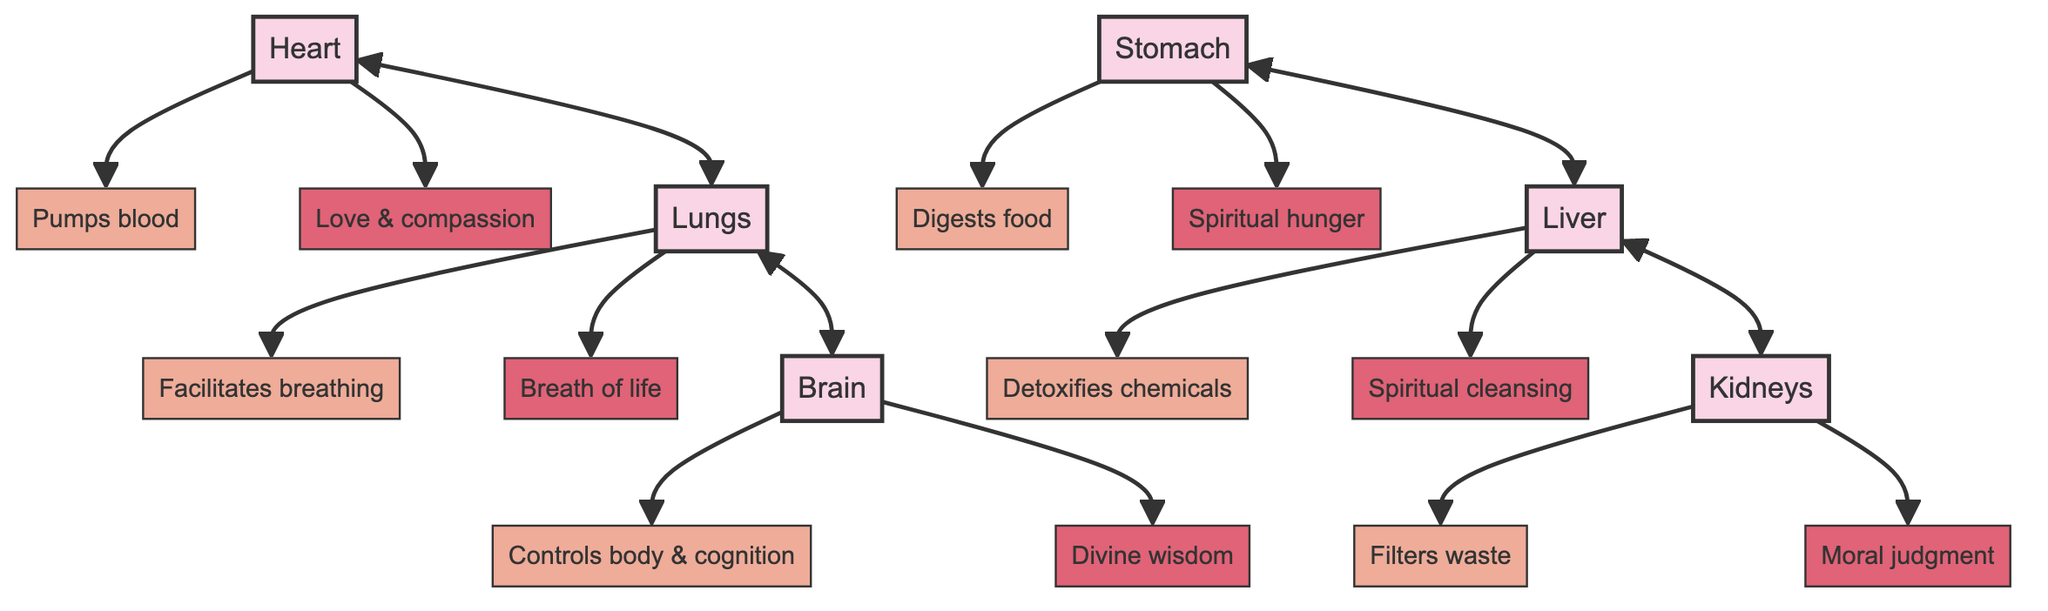What is the function of the heart? The heart is connected to the node labeled "Pumps blood," which directly indicates its primary function in the diagram.
Answer: Pumps blood What spiritual symbolism is associated with the brain? The brain is linked to "Divine wisdom," which is shown next to the brain in the diagram, representing its spiritual interpretation.
Answer: Divine wisdom Which organ is connected to both the liver and kidneys? The diagram shows a direct connection between the liver and kidneys, indicating that the liver is associated with the kidneys in their relationships.
Answer: Liver How many organs are represented in the diagram? By counting the distinct organ nodes labeled in the diagram, there are a total of six organs: heart, lungs, brain, liver, kidneys, and stomach.
Answer: 6 What is the symbolism associated with the lungs? The lungs are associated with "Breath of life," as specified next to the lungs in the diagram, which embodies its spiritual interpretation.
Answer: Breath of life What is the relationship between the stomach and liver? The diagram indicates a connection between the stomach and the liver, suggesting an interaction or influence between these two organs.
Answer: Connected Which organ is responsible for detoxification? The function node connected to the liver states "Detoxifies chemicals," which directly addresses the organ responsible for detoxification in the body.
Answer: Liver Which organ’s function involves waste filtering? The kidneys' function node is labeled "Filters waste," clearly indicating that this organ is responsible for filtering waste products from the body.
Answer: Kidneys How does the heart relate to the lungs? There is a bidirectional connection between the heart and lungs in the diagram, indicating a significant relationship where both organs contribute to each other's functions.
Answer: Connected What does the stomach symbolize spiritually? The stomach is linked to the symbolism node "Spiritual hunger," which denotes its spiritual meaning according to the diagram.
Answer: Spiritual hunger 